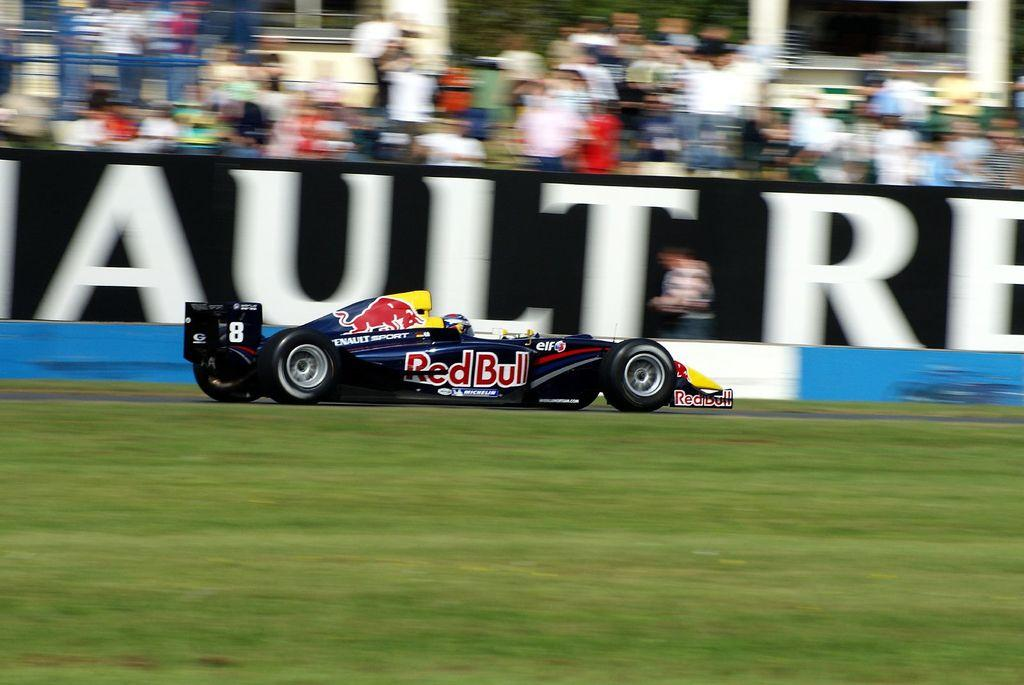What is located on the ground in the image? There is a vehicle on the ground in the image. What can be seen in the background of the image? There is a board and people visible in the background of the image. What architectural features are present in the background of the image? There are pillars in the background of the image. What safety feature is present in the image? There is a railing in the image. What type of liquid is being poured by the beginner in the image? There is no beginner or liquid present in the image. 